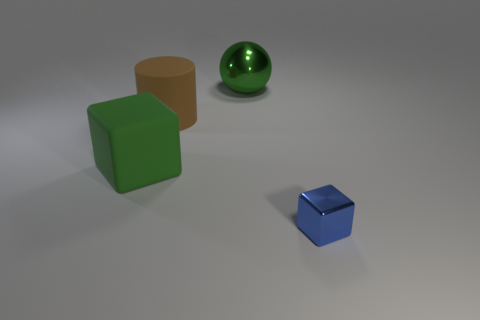Add 4 metal spheres. How many objects exist? 8 Subtract all spheres. How many objects are left? 3 Add 2 green blocks. How many green blocks exist? 3 Subtract 0 gray cylinders. How many objects are left? 4 Subtract all purple cubes. Subtract all blue cylinders. How many cubes are left? 2 Subtract all green matte things. Subtract all large objects. How many objects are left? 0 Add 1 matte blocks. How many matte blocks are left? 2 